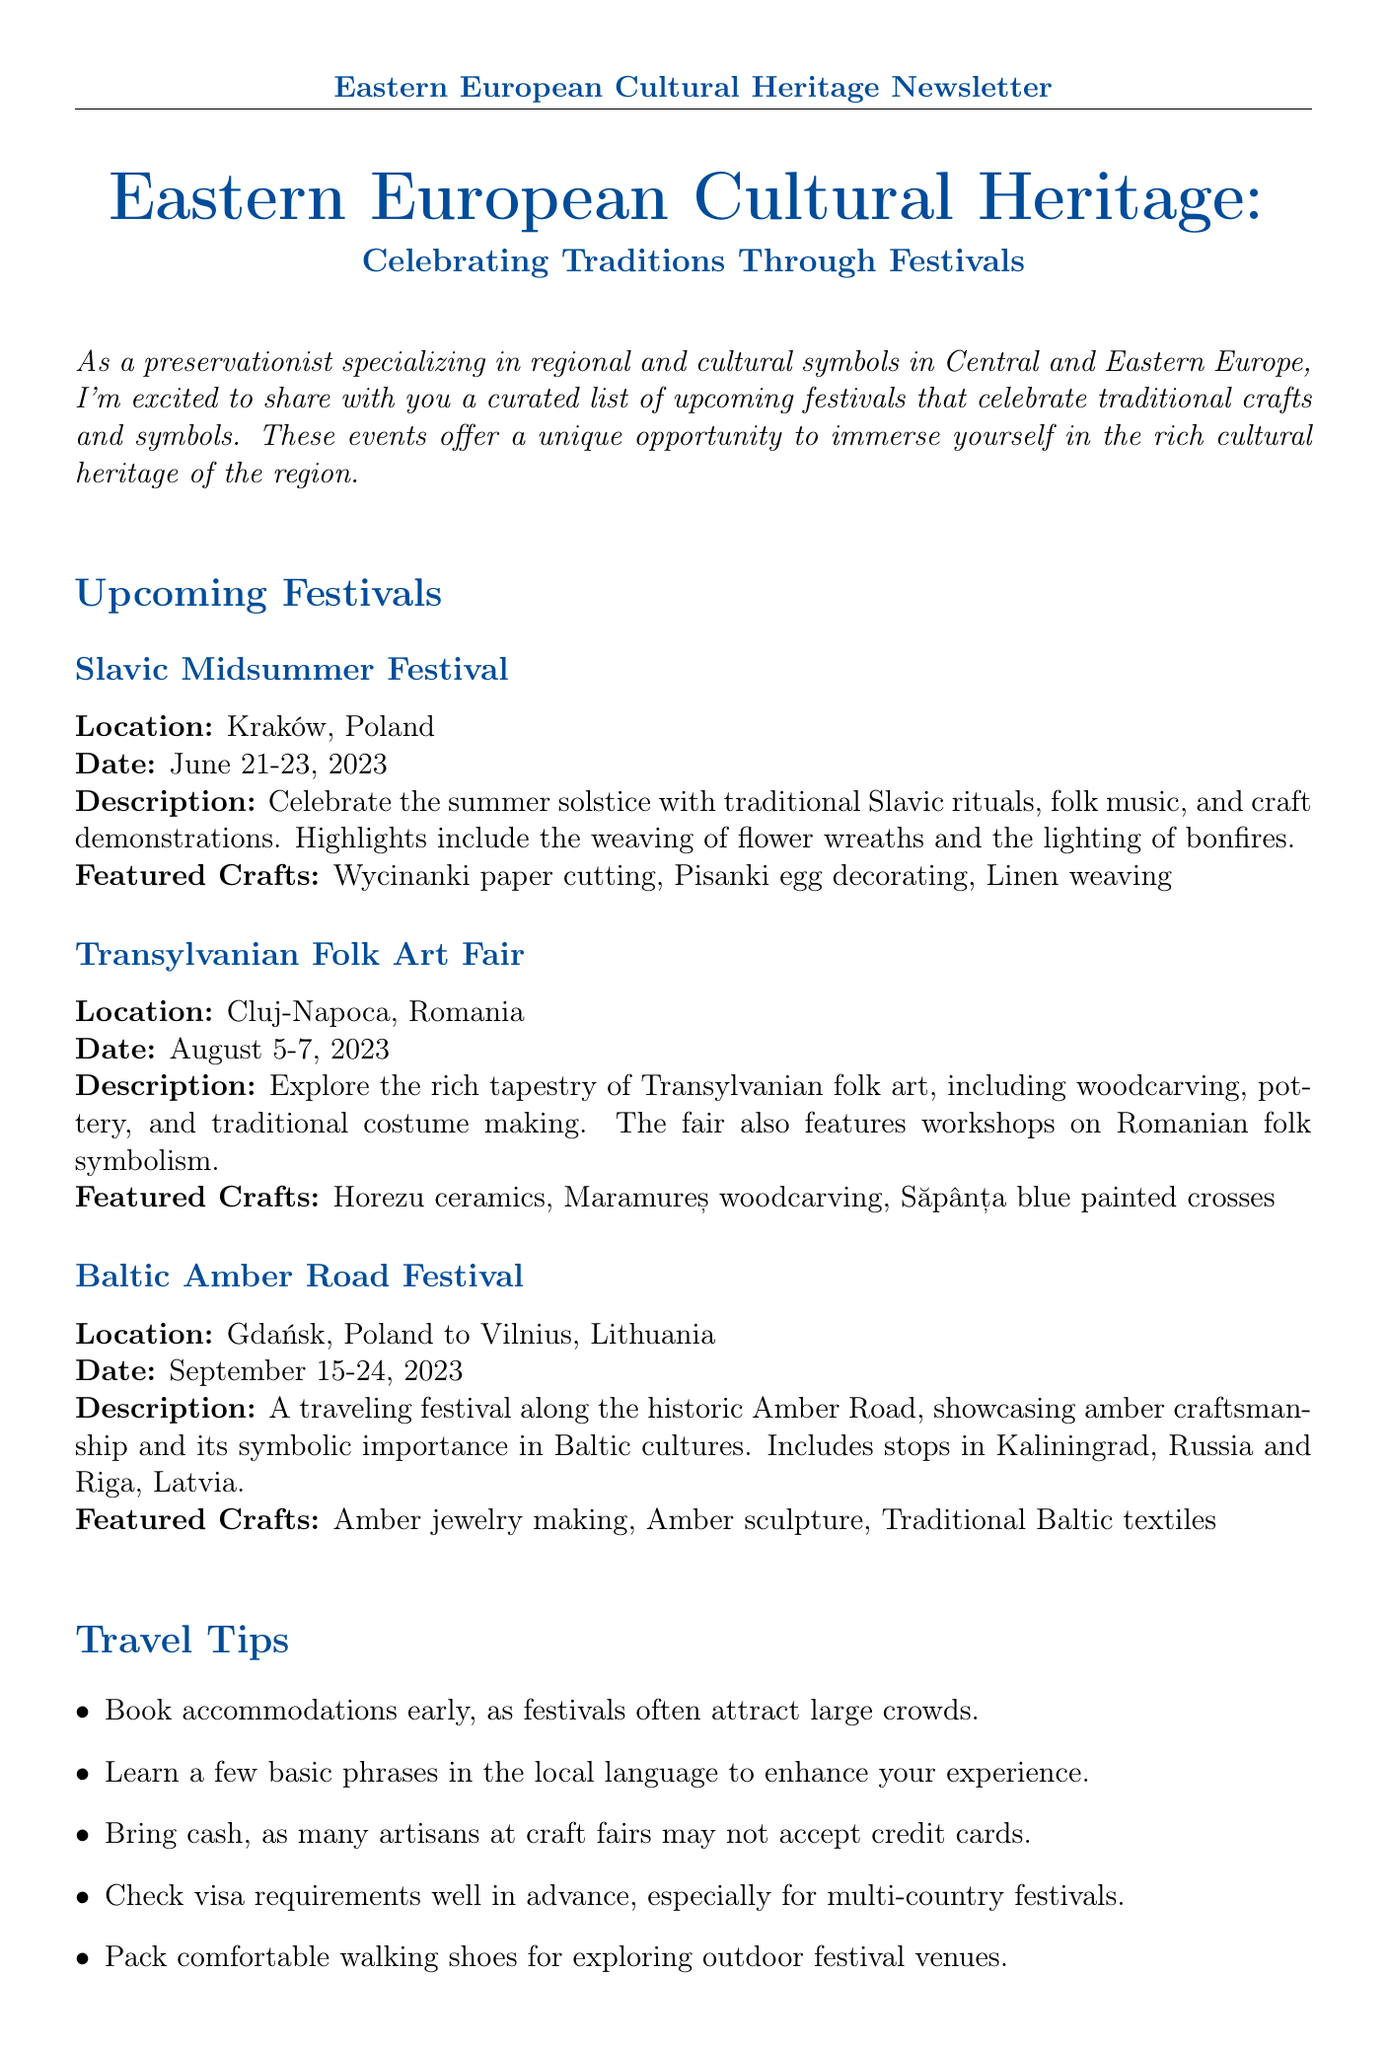What is the title of the newsletter? The title of the newsletter is stated at the top as "Eastern European Cultural Heritage: Celebrating Traditions Through Festivals."
Answer: Eastern European Cultural Heritage: Celebrating Traditions Through Festivals What is the location of the Slavic Midsummer Festival? The document lists Kraków, Poland as the location of the Slavic Midsummer Festival.
Answer: Kraków, Poland When does the Transylvanian Folk Art Fair take place? The date for the Transylvanian Folk Art Fair is provided in the document as August 5-7, 2023.
Answer: August 5-7, 2023 What are two featured crafts at the Baltic Amber Road Festival? The document lists several crafts, and two of them are amber jewelry making and amber sculpture.
Answer: Amber jewelry making, Amber sculpture How many travel tips are provided in the newsletter? The document lists five travel tips under the section titled Travel Tips.
Answer: Five What common theme can be found in the featured crafts across the festivals? The crafts focus on traditional techniques and regional symbolism, reflecting the cultural heritage of Eastern Europe.
Answer: Traditional techniques and regional symbolism Which festival includes workshops on Romanian folk symbolism? The description specifically mentions workshops on Romanian folk symbolism at the Transylvanian Folk Art Fair.
Answer: Transylvanian Folk Art Fair What is the purpose of attending these festivals according to the conclusion? The conclusion emphasizes that attending these festivals allows one to witness craftsmanship and contributes to preservation efforts of cultural traditions.
Answer: Witnessing craftsmanship and contributing to preservation efforts 